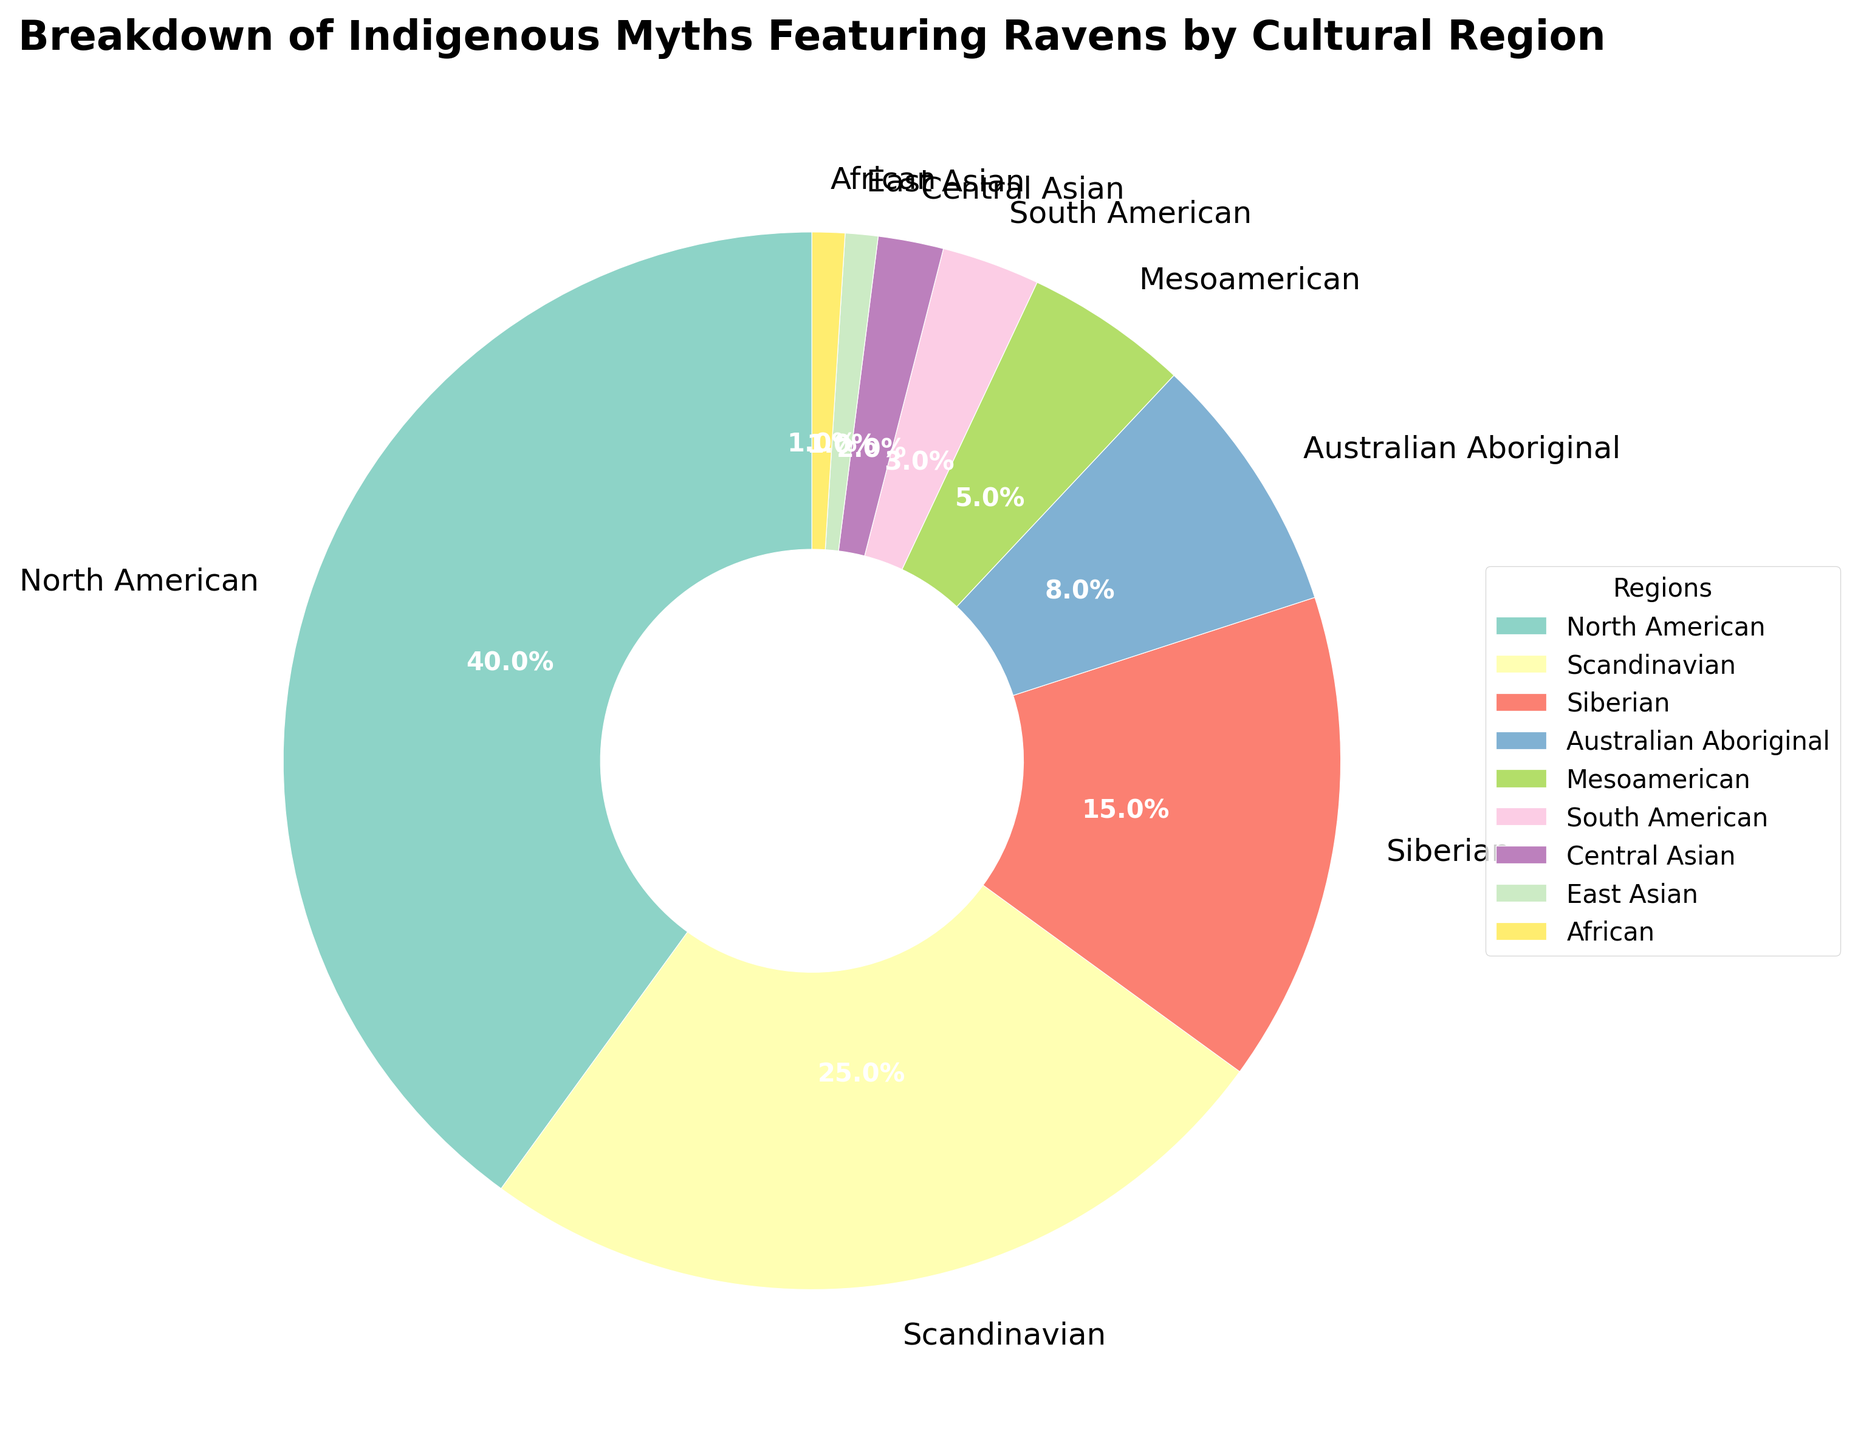Which cultural region has the highest percentage of Indigenous myths featuring ravens? Look for the region with the largest slice in the pie chart. North American has the biggest segment.
Answer: North American What is the combined percentage of Indigenous myths featuring ravens for North American and Scandinavian regions? Sum the percentages of North American (40%) and Scandinavian (25%). 40 + 25 = 65
Answer: 65% Which region has a larger percentage, Siberian or Australian Aboriginal? Compare the percentages of Siberian (15%) and Australian Aboriginal (8%). Siberian is larger.
Answer: Siberian What is the smallest percentage depicted in the chart, and which region does it correspond to? Identify the smallest percentage among all segments. Both East Asian and African are tied at 1%.
Answer: 1%, East Asian and African By how much does the North American percentage exceed the sum of African, East Asian, and Central Asian percentages? First, sum the African (1%), East Asian (1%), and Central Asian (2%) percentages: 1 + 1 + 2 = 4. Then, subtract this sum from the North American percentage: 40 - 4 = 36
Answer: 36 If we combine the percentages of Mesoamerican, South American, and Central Asian myths, what fraction of the total pie chart do they represent? Sum the percentages of Mesoamerican (5%), South American (3%), and Central Asian (2%): 5 + 3 + 2 = 10. Since the total of all segments is 100%, 10% is 10/100, which simplifies to 1/10.
Answer: 1/10 Which regions collectively make up less than 10% of the pie chart? Identify regions with percentages individually less than 10% and whose collective sum is also less than 10%. African (1%), East Asian (1%), and Central Asian (2%) collectively sum to 4%, which is less than 10%.
Answer: African, East Asian, Central Asian What is the difference between the percentage of Siberian and Australian Aboriginal myths? Subtract the Australian Aboriginal percentage from the Siberian percentage: 15 - 8.
Answer: 7 Which region has the highest percentage of Indigenous myths featuring ravens outside of North American and Scandinavian regions? Exclude North American and Scandinavian, then identify the next largest segment. The Siberian region has 15%.
Answer: Siberian What is the percentage difference between the combined values of Scandinavian and Siberian myths and that of North American myths? Sum the Scandinavian (25%) and Siberian (15%) percentages: 25 + 15 = 40, which equals the North American percentage. The difference is 0.
Answer: 0 